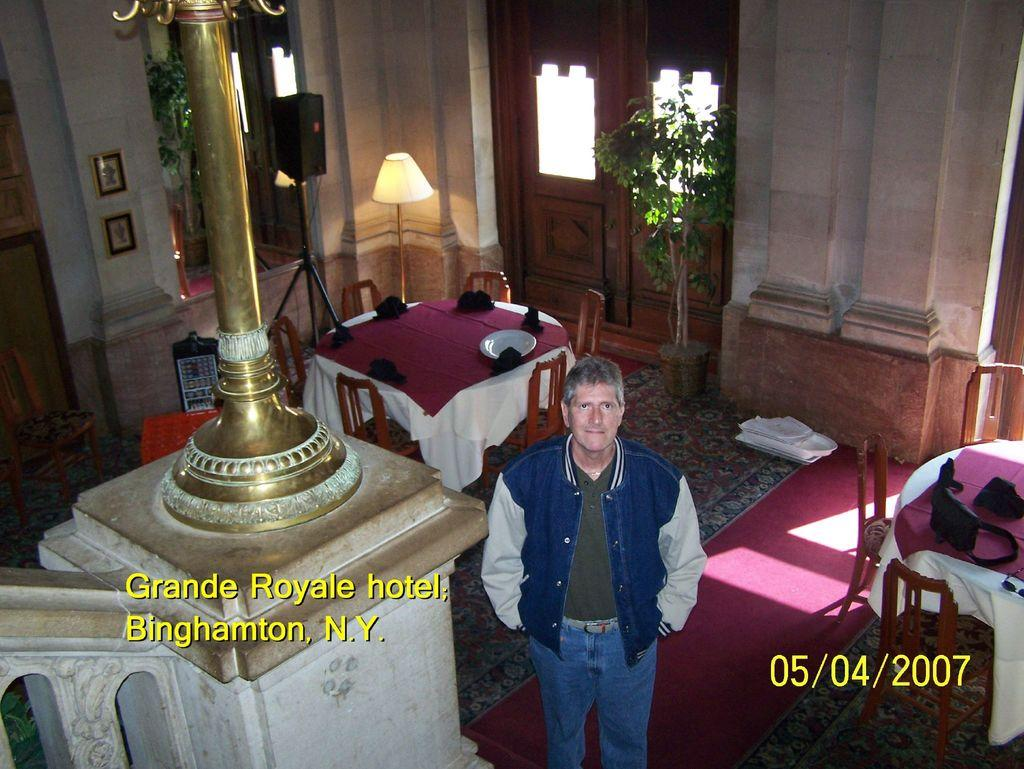What is located on the left side of the image? There is a man standing on the left side of the image. What can be seen in the background of the image? There is a pole in the background of the image. What type of furniture is present in the image? There is a dining table in the image. What is on the dining table? There is a plate and a cloth on the dining table. What type of plant is in the image? There is a small plant in the image. What type of lighting is present in the image? There is a lamp in the image. What architectural feature can be seen in the image? There is a door in the image. What type of structure is visible in the image? There is a wall in the image. Can you tell me how many bees are buzzing around the small plant in the image? There are no bees present in the image; it only features a small plant. What type of potato is being used as a doorstop in the image? There is no potato present in the image, nor is there a doorstop. --- Facts: 1. There is a car in the image. 2. The car is red. 3. The car has four wheels. 4. There is a road in the image. 5. The road is paved. 6. There are trees on both sides of the road. 7. The sky is visible in the image. 8. The sun is visible in the sky. Absurd Topics: elephant, umbrella, ocean Conversation: What is the main subject of the image? The main subject of the image is a car. What color is the car? The car is red. How many wheels does the car have? The car has four wheels. What type of surface can be seen in the image? There is a road in the image, and it is paved. What type of vegetation is present on both sides of the road? There are trees on both sides of the road. What is visible in the sky in the image? The sky is visible in the image, and the sun is visible in the sky. Reasoning: Let's think step by step in order to produce the conversation. We start by identifying the main subject in the image, which is the car. Then, we expand the conversation to include other items that are also visible, such as the car's color, the number of wheels, the road, the trees, and the sky. Each question is designed to elicit a specific detail about the image that is known from the provided facts. Absurd Question/Answer: Can you tell me how many elephants are crossing the road in the image? There are no elephants present in the image; it only features a car and a road. 